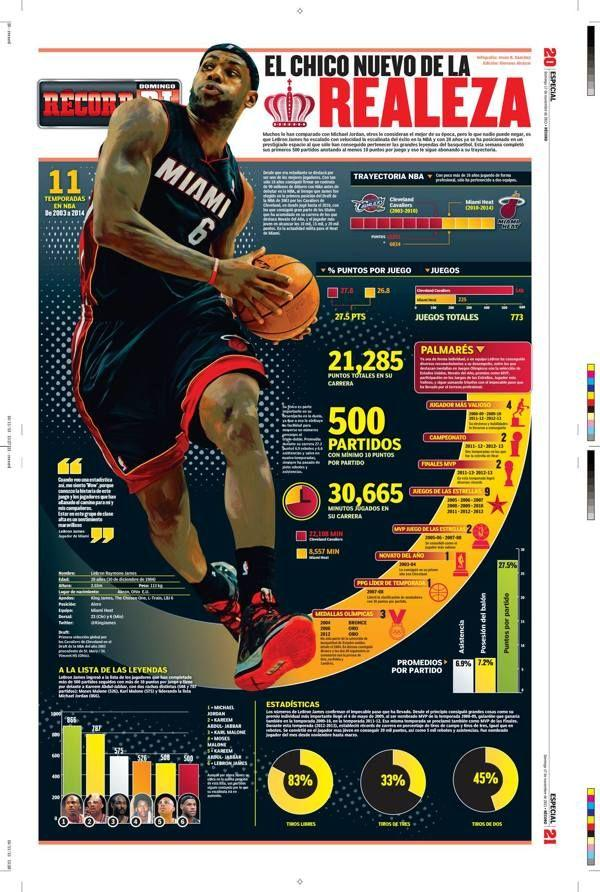Point out several critical features in this image. The team name written on the T-shirt is Miami. 